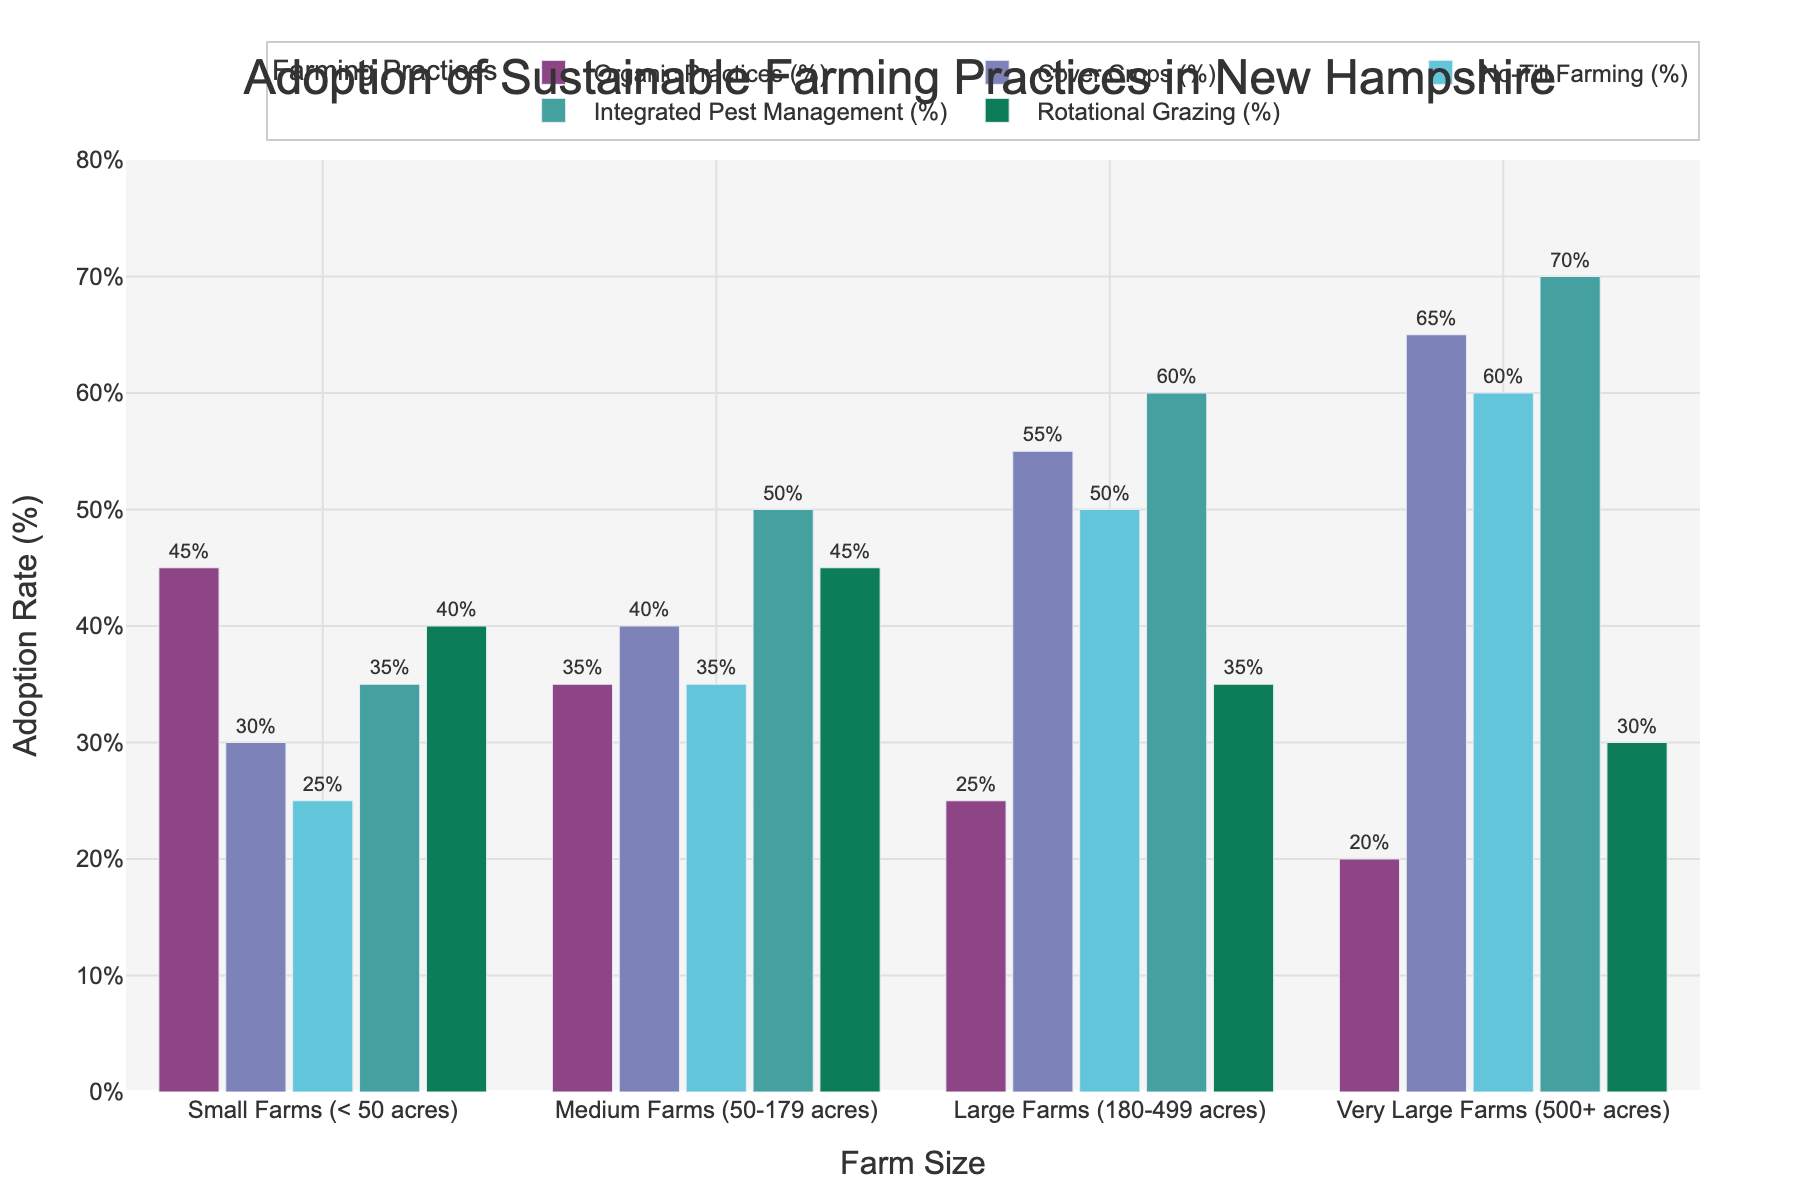What is the adoption rate of No-Till Farming for Very Large Farms? Look at the bar for No-Till Farming corresponding to Very Large Farms. The height of the bar shows an adoption rate of 60%.
Answer: 60% Which farming practice has the highest adoption rate among Medium Farms? Look at the adoption rates for each practice within Medium Farms. The highest bar is for Integrated Pest Management at 50%.
Answer: Integrated Pest Management How does the adoption rate of Organic Practices compare between Small and Large Farms? Compare the height of the bars for Organic Practices between Small and Large Farms. Small Farms have a rate of 45%, and Large Farms have a rate of 25%. Small Farms have a higher rate.
Answer: Small Farms have a higher rate What is the combined adoption rate of Cover Crops and Rotational Grazing for Small Farms? Add the adoption rates of Cover Crops (30%) and Rotational Grazing (40%) for Small Farms. 30% + 40% = 70%.
Answer: 70% Which farming practice shows the largest difference in adoption rates between Small and Very Large Farms? Calculate the differences in adoption rates for each practice between Small and Very Large Farms: Organic Practices (25%), Cover Crops (35%), No-Till Farming (35%), Integrated Pest Management (35%), Rotational Grazing (10%). The largest difference is for Cover Crops.
Answer: Cover Crops Are there any practices where Large Farms have a higher adoption rate than Very Large Farms? Compare the adoption rates for each practice between Large Farms and Very Large Farms. For all practices (Organic Practices, Cover Crops, No-Till Farming, Integrated Pest Management, Rotational Grazing), Large Farms always have a lower rate than Very Large Farms.
Answer: No Which farm size has the highest adoption rate for Cover Crops? Look at the adoption rates for Cover Crops across all farm sizes. The highest bar for Cover Crops is for Very Large Farms at 65%.
Answer: Very Large Farms What is the average adoption rate of Integrated Pest Management across all farm sizes? Add the adoption rates of Integrated Pest Management for all farm sizes and divide by the number of farm sizes: (35% + 50% + 60% + 70%) / 4 = 215% / 4 = 53.75%.
Answer: 53.75% What is the difference in the adoption rate of Rotational Grazing between Small Farms and Medium Farms? Subtract the adoption rate of Rotational Grazing for Small Farms (40%) from Medium Farms (45%). 45% - 40% = 5%.
Answer: 5% 